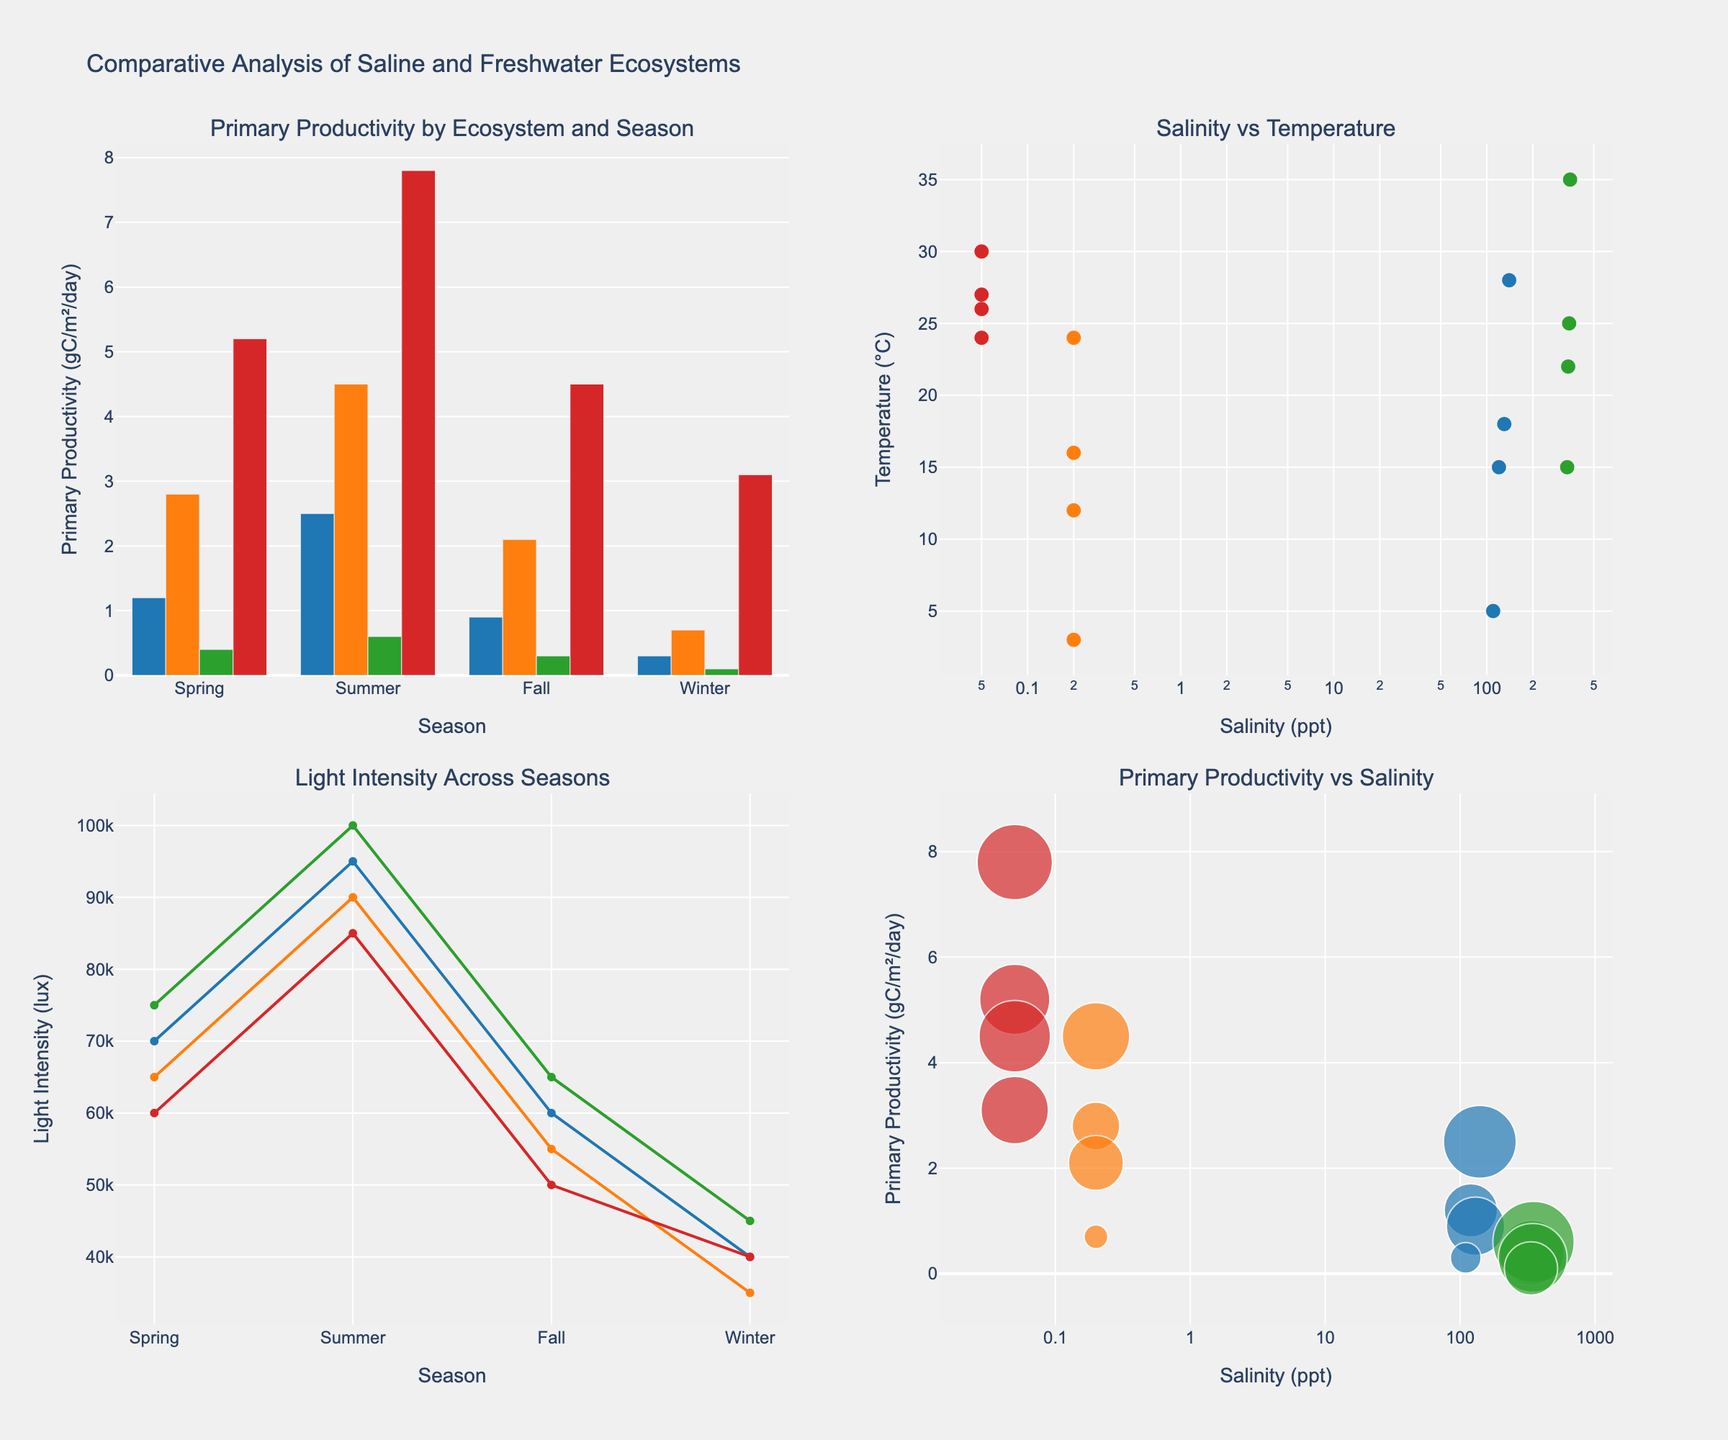What is the primary productivity of Lake Michigan in the summer? Look at the bar chart in the first subplot. Find Lake Michigan and the summer season. The bar height represents the primary productivity.
Answer: 4.5 gC/m²/day Which ecosystem has the highest primary productivity in the spring? In the bar chart of primary productivity by ecosystem and season (first subplot), compare the spring values across all ecosystems. Identify the highest bar.
Answer: Amazon River How does salinity relate to temperature in the Great Salt Lake? Refer to the scatter plot in the second subplot. Locate points representing the Great Salt Lake and observe the relationship trend between salinity and temperature.
Answer: As salinity increases, temperature varies but generally ranges between 5°C-28°C What is the range of light intensity for the Amazon River? Check the line plot (third subplot) for the light intensity values of the Amazon River over different seasons. Identify the minimum and maximum values.
Answer: 40,000 to 85,000 lux Which ecosystem exhibits the lowest primary productivity, and in which season does this occur? Examine the bar chart in the first subplot, looking for the smallest bar. Note the corresponding ecosystem and season.
Answer: Dead Sea, Winter In which season does the Dead Sea have the highest temperature? For the scatter plot of salinity vs. temperature (second subplot), focus on the Dead Sea's points and identify the point with the highest temperature value, noting its corresponding season.
Answer: Summer By comparing the primary productivity in spring, which ecosystem has the least productivity? In the bar chart of the first subplot, compare the heights of the bars for each ecosystem during the spring season. Identify the shortest bar.
Answer: Dead Sea What relationship can you observe between primary productivity and salinity in the second subplot? Look at the scatter plot (fourth subplot) and observe the general trend. Note how primary productivity changes as salinity varies.
Answer: Higher salinity corresponds to lower primary productivity How is the light intensity for the Great Salt Lake in fall compared to Lake Michigan in fall? In the line plot (third subplot), compare the light intensity values for the Great Salt Lake and Lake Michigan during the fall.
Answer: Great Salt Lake: 60,000 lux; Lake Michigan: 55,000 lux What is the general trend of salinity levels across the ecosystems? Refer to the relevant subplots showing salinity data points (such as the second subplot). Observe how salinity levels correspond across different ecosystems.
Answer: Dead Sea > Great Salt Lake > Lake Michigan ≈ Amazon River 